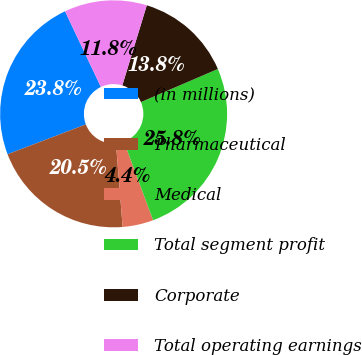Convert chart. <chart><loc_0><loc_0><loc_500><loc_500><pie_chart><fcel>(in millions)<fcel>Pharmaceutical<fcel>Medical<fcel>Total segment profit<fcel>Corporate<fcel>Total operating earnings<nl><fcel>23.76%<fcel>20.47%<fcel>4.39%<fcel>25.81%<fcel>13.81%<fcel>11.76%<nl></chart> 